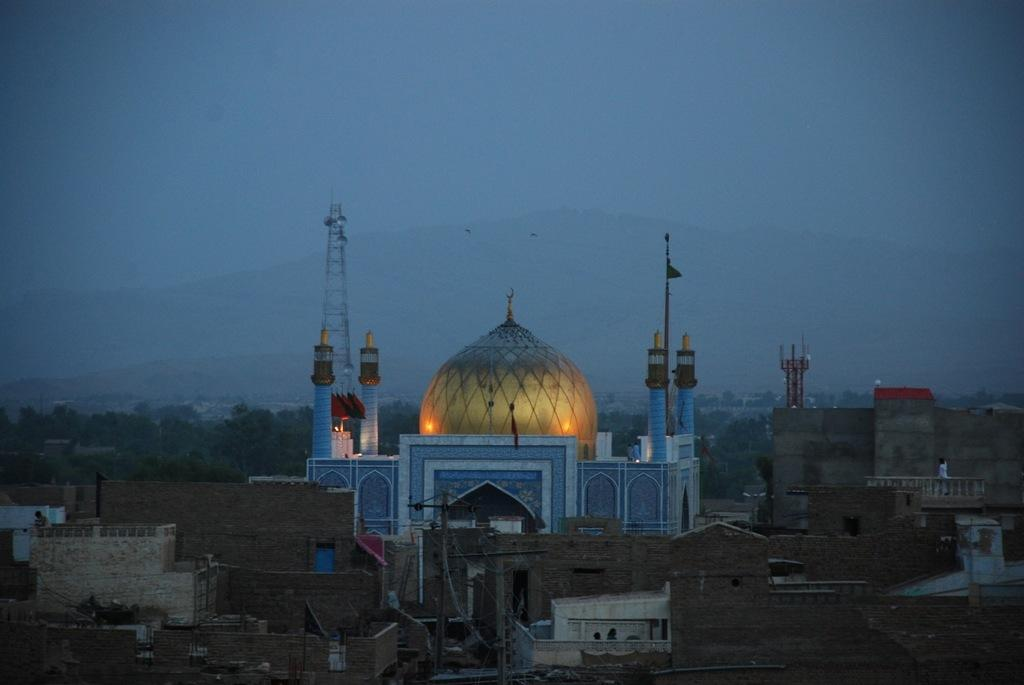What is located in the center of the image? There are buildings in the center of the image. What can be seen in the background of the image? There are trees and a tower in the background of the image. How many waves can be seen crashing against the buildings in the image? There are no waves present in the image; it features buildings, trees, and a tower. What type of corn is growing near the tower in the image? There is no corn present in the image; it only features buildings, trees, and a tower. 